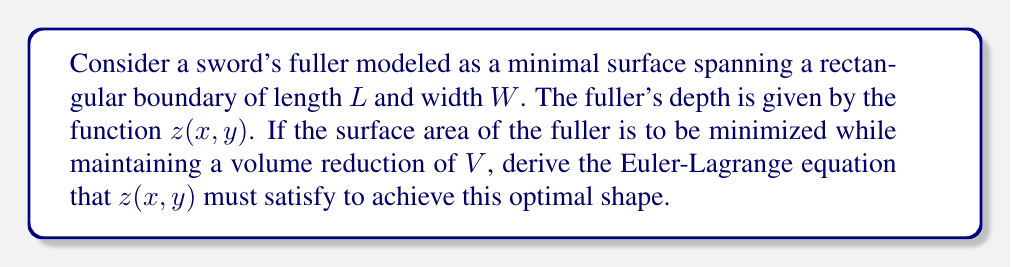Solve this math problem. To solve this problem, we'll follow these steps:

1) The surface area of the fuller is given by the functional:

   $$A[z] = \int_0^L \int_0^W \sqrt{1 + (\frac{\partial z}{\partial x})^2 + (\frac{\partial z}{\partial y})^2} dx dy$$

2) The volume reduction constraint can be expressed as:

   $$V = \int_0^L \int_0^W z(x,y) dx dy$$

3) We need to minimize $A[z]$ subject to the constraint on $V$. This is a variational problem with a constraint, which can be solved using the method of Lagrange multipliers.

4) Form the Lagrangian:

   $$\mathcal{L}[z] = \int_0^L \int_0^W \left[\sqrt{1 + (\frac{\partial z}{\partial x})^2 + (\frac{\partial z}{\partial y})^2} + \lambda z(x,y)\right] dx dy$$

   where $\lambda$ is the Lagrange multiplier.

5) The Euler-Lagrange equation for this functional is:

   $$\frac{\partial}{\partial x}\left(\frac{\partial \mathcal{L}}{\partial z_x}\right) + \frac{\partial}{\partial y}\left(\frac{\partial \mathcal{L}}{\partial z_y}\right) - \frac{\partial \mathcal{L}}{\partial z} = 0$$

6) Calculating the partial derivatives:

   $$\frac{\partial \mathcal{L}}{\partial z_x} = \frac{z_x}{\sqrt{1 + z_x^2 + z_y^2}}$$
   
   $$\frac{\partial \mathcal{L}}{\partial z_y} = \frac{z_y}{\sqrt{1 + z_x^2 + z_y^2}}$$
   
   $$\frac{\partial \mathcal{L}}{\partial z} = \lambda$$

7) Substituting into the Euler-Lagrange equation:

   $$\frac{\partial}{\partial x}\left(\frac{z_x}{\sqrt{1 + z_x^2 + z_y^2}}\right) + \frac{\partial}{\partial y}\left(\frac{z_y}{\sqrt{1 + z_x^2 + z_y^2}}\right) = \lambda$$

8) This equation can be written in a more compact form using the mean curvature $H$:

   $$2H = \lambda$$

   where $H = \frac{1}{2}\nabla \cdot \left(\frac{\nabla z}{\sqrt{1 + |\nabla z|^2}}\right)$
Answer: $2H = \lambda$, where $H = \frac{1}{2}\nabla \cdot \left(\frac{\nabla z}{\sqrt{1 + |\nabla z|^2}}\right)$ 